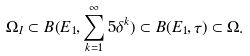<formula> <loc_0><loc_0><loc_500><loc_500>\Omega _ { I } \subset B ( E _ { 1 } , \sum _ { k = 1 } ^ { \infty } 5 \delta ^ { k } ) \subset B ( E _ { 1 } , \tau ) \subset \Omega .</formula> 